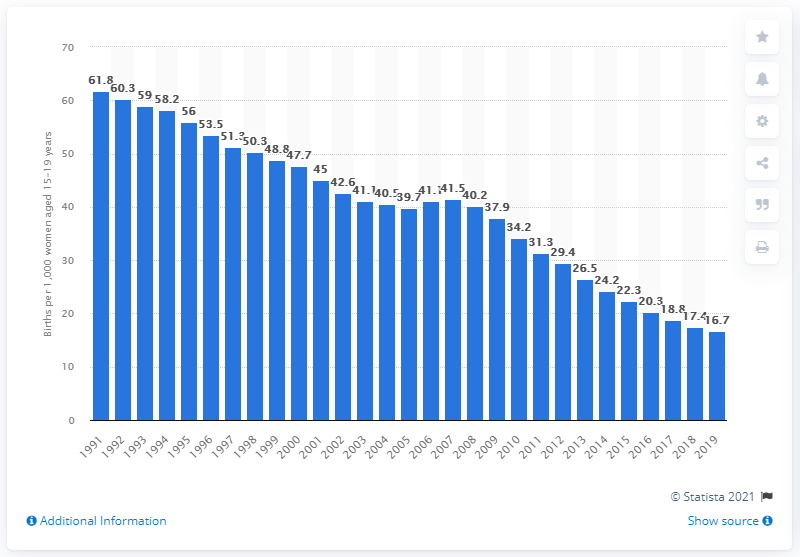List a handful of essential elements in this visual. In 2019, the teenage birth rate in the United States was 16.7 births per every thousand women aged 15-19. 